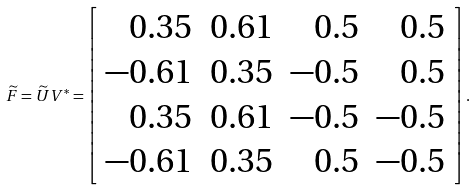Convert formula to latex. <formula><loc_0><loc_0><loc_500><loc_500>\widetilde { F } = \widetilde { U } V ^ { * } = \left [ \begin{array} { r r r r } 0 . 3 5 & 0 . 6 1 & 0 . 5 & 0 . 5 \\ - 0 . 6 1 & 0 . 3 5 & - 0 . 5 & 0 . 5 \\ 0 . 3 5 & 0 . 6 1 & - 0 . 5 & - 0 . 5 \\ - 0 . 6 1 & 0 . 3 5 & 0 . 5 & - 0 . 5 \end{array} \right ] .</formula> 